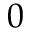<formula> <loc_0><loc_0><loc_500><loc_500>0</formula> 